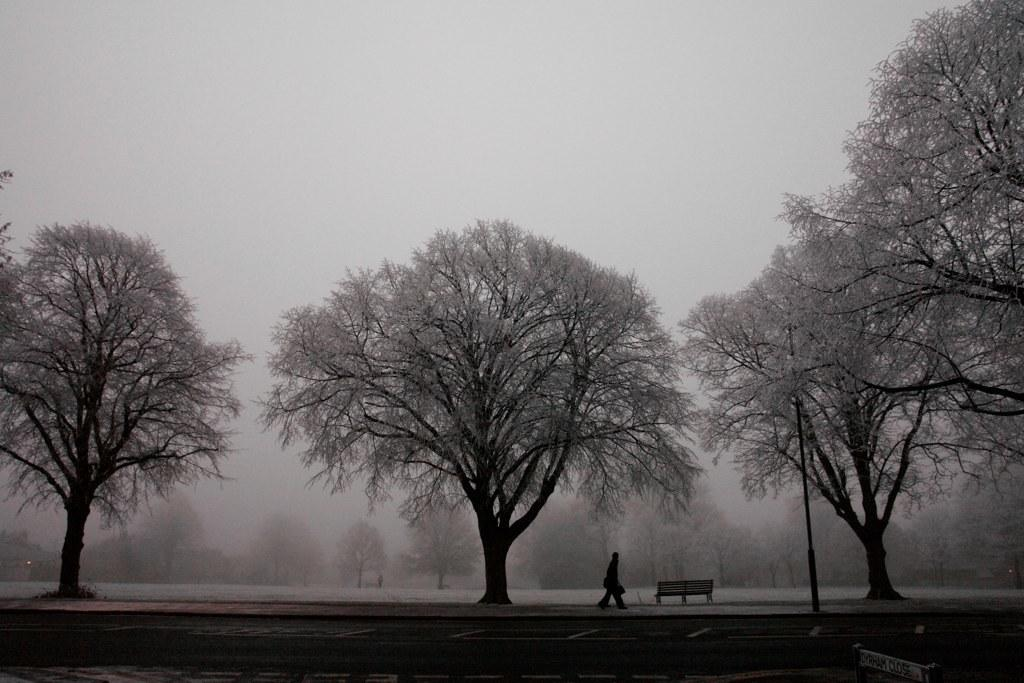What type of seating is visible in the image? There is a bench in the image. Who is present in the image? There is a man at the bottom side of the image. What type of vegetation is present in the image? There are trees in the image. What is the condition of the trees and ground in the image? The trees and the ground are covered with snow. Can you see a pipe being used by the man in the image? There is no pipe visible in the image, nor is the man using one. What suggestion does the man in the image have for the viewer? The image does not provide any information about the man's suggestions or intentions. 